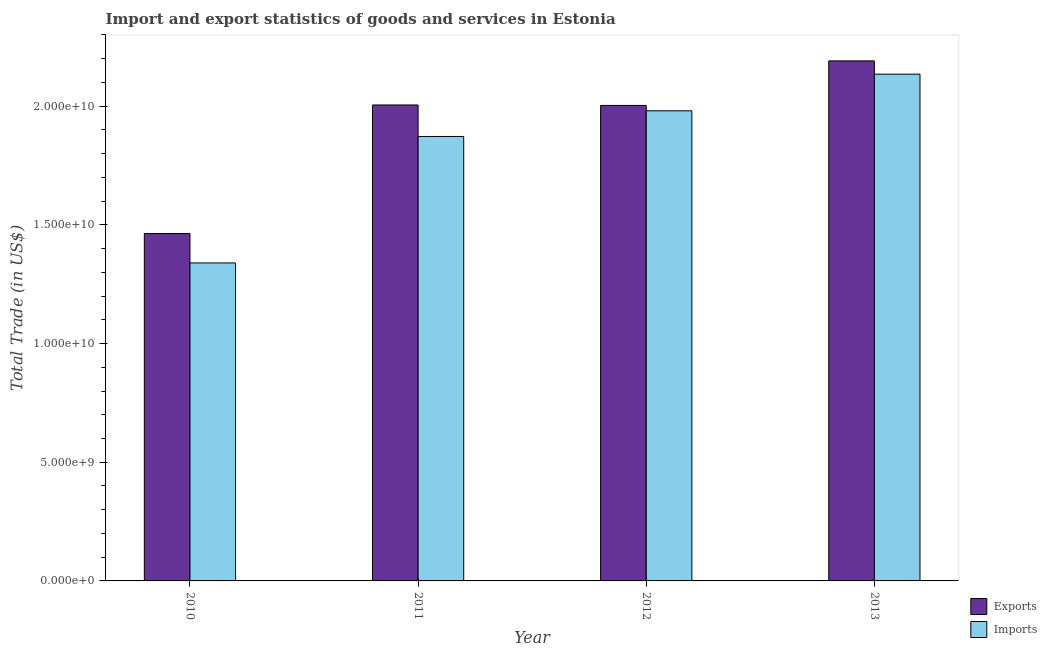Are the number of bars per tick equal to the number of legend labels?
Offer a terse response. Yes. How many bars are there on the 1st tick from the left?
Offer a very short reply. 2. How many bars are there on the 4th tick from the right?
Give a very brief answer. 2. What is the label of the 4th group of bars from the left?
Offer a very short reply. 2013. In how many cases, is the number of bars for a given year not equal to the number of legend labels?
Offer a very short reply. 0. What is the export of goods and services in 2012?
Offer a terse response. 2.00e+1. Across all years, what is the maximum imports of goods and services?
Give a very brief answer. 2.13e+1. Across all years, what is the minimum export of goods and services?
Your answer should be very brief. 1.46e+1. What is the total imports of goods and services in the graph?
Your response must be concise. 7.33e+1. What is the difference between the imports of goods and services in 2010 and that in 2012?
Keep it short and to the point. -6.41e+09. What is the difference between the export of goods and services in 2010 and the imports of goods and services in 2013?
Offer a terse response. -7.27e+09. What is the average export of goods and services per year?
Keep it short and to the point. 1.92e+1. What is the ratio of the imports of goods and services in 2011 to that in 2013?
Give a very brief answer. 0.88. Is the difference between the imports of goods and services in 2010 and 2012 greater than the difference between the export of goods and services in 2010 and 2012?
Ensure brevity in your answer.  No. What is the difference between the highest and the second highest export of goods and services?
Make the answer very short. 1.86e+09. What is the difference between the highest and the lowest export of goods and services?
Your answer should be compact. 7.27e+09. In how many years, is the export of goods and services greater than the average export of goods and services taken over all years?
Make the answer very short. 3. What does the 2nd bar from the left in 2010 represents?
Your answer should be very brief. Imports. What does the 2nd bar from the right in 2011 represents?
Provide a short and direct response. Exports. How many years are there in the graph?
Keep it short and to the point. 4. Where does the legend appear in the graph?
Make the answer very short. Bottom right. How many legend labels are there?
Offer a very short reply. 2. How are the legend labels stacked?
Provide a succinct answer. Vertical. What is the title of the graph?
Ensure brevity in your answer.  Import and export statistics of goods and services in Estonia. What is the label or title of the X-axis?
Provide a succinct answer. Year. What is the label or title of the Y-axis?
Ensure brevity in your answer.  Total Trade (in US$). What is the Total Trade (in US$) in Exports in 2010?
Make the answer very short. 1.46e+1. What is the Total Trade (in US$) in Imports in 2010?
Give a very brief answer. 1.34e+1. What is the Total Trade (in US$) of Exports in 2011?
Offer a terse response. 2.01e+1. What is the Total Trade (in US$) in Imports in 2011?
Ensure brevity in your answer.  1.87e+1. What is the Total Trade (in US$) of Exports in 2012?
Make the answer very short. 2.00e+1. What is the Total Trade (in US$) of Imports in 2012?
Offer a terse response. 1.98e+1. What is the Total Trade (in US$) of Exports in 2013?
Make the answer very short. 2.19e+1. What is the Total Trade (in US$) in Imports in 2013?
Ensure brevity in your answer.  2.13e+1. Across all years, what is the maximum Total Trade (in US$) of Exports?
Offer a very short reply. 2.19e+1. Across all years, what is the maximum Total Trade (in US$) in Imports?
Your answer should be compact. 2.13e+1. Across all years, what is the minimum Total Trade (in US$) of Exports?
Ensure brevity in your answer.  1.46e+1. Across all years, what is the minimum Total Trade (in US$) of Imports?
Ensure brevity in your answer.  1.34e+1. What is the total Total Trade (in US$) in Exports in the graph?
Provide a succinct answer. 7.66e+1. What is the total Total Trade (in US$) in Imports in the graph?
Ensure brevity in your answer.  7.33e+1. What is the difference between the Total Trade (in US$) of Exports in 2010 and that in 2011?
Provide a short and direct response. -5.42e+09. What is the difference between the Total Trade (in US$) in Imports in 2010 and that in 2011?
Make the answer very short. -5.33e+09. What is the difference between the Total Trade (in US$) of Exports in 2010 and that in 2012?
Your answer should be compact. -5.40e+09. What is the difference between the Total Trade (in US$) in Imports in 2010 and that in 2012?
Keep it short and to the point. -6.41e+09. What is the difference between the Total Trade (in US$) of Exports in 2010 and that in 2013?
Your response must be concise. -7.27e+09. What is the difference between the Total Trade (in US$) in Imports in 2010 and that in 2013?
Keep it short and to the point. -7.95e+09. What is the difference between the Total Trade (in US$) of Exports in 2011 and that in 2012?
Ensure brevity in your answer.  1.93e+07. What is the difference between the Total Trade (in US$) in Imports in 2011 and that in 2012?
Keep it short and to the point. -1.08e+09. What is the difference between the Total Trade (in US$) in Exports in 2011 and that in 2013?
Your response must be concise. -1.86e+09. What is the difference between the Total Trade (in US$) in Imports in 2011 and that in 2013?
Offer a very short reply. -2.63e+09. What is the difference between the Total Trade (in US$) in Exports in 2012 and that in 2013?
Your response must be concise. -1.88e+09. What is the difference between the Total Trade (in US$) of Imports in 2012 and that in 2013?
Ensure brevity in your answer.  -1.54e+09. What is the difference between the Total Trade (in US$) in Exports in 2010 and the Total Trade (in US$) in Imports in 2011?
Provide a short and direct response. -4.09e+09. What is the difference between the Total Trade (in US$) of Exports in 2010 and the Total Trade (in US$) of Imports in 2012?
Your response must be concise. -5.17e+09. What is the difference between the Total Trade (in US$) of Exports in 2010 and the Total Trade (in US$) of Imports in 2013?
Provide a succinct answer. -6.71e+09. What is the difference between the Total Trade (in US$) in Exports in 2011 and the Total Trade (in US$) in Imports in 2012?
Give a very brief answer. 2.46e+08. What is the difference between the Total Trade (in US$) in Exports in 2011 and the Total Trade (in US$) in Imports in 2013?
Make the answer very short. -1.30e+09. What is the difference between the Total Trade (in US$) of Exports in 2012 and the Total Trade (in US$) of Imports in 2013?
Keep it short and to the point. -1.32e+09. What is the average Total Trade (in US$) of Exports per year?
Ensure brevity in your answer.  1.92e+1. What is the average Total Trade (in US$) of Imports per year?
Provide a short and direct response. 1.83e+1. In the year 2010, what is the difference between the Total Trade (in US$) of Exports and Total Trade (in US$) of Imports?
Your response must be concise. 1.24e+09. In the year 2011, what is the difference between the Total Trade (in US$) in Exports and Total Trade (in US$) in Imports?
Make the answer very short. 1.33e+09. In the year 2012, what is the difference between the Total Trade (in US$) in Exports and Total Trade (in US$) in Imports?
Provide a succinct answer. 2.26e+08. In the year 2013, what is the difference between the Total Trade (in US$) in Exports and Total Trade (in US$) in Imports?
Ensure brevity in your answer.  5.60e+08. What is the ratio of the Total Trade (in US$) in Exports in 2010 to that in 2011?
Make the answer very short. 0.73. What is the ratio of the Total Trade (in US$) of Imports in 2010 to that in 2011?
Your answer should be very brief. 0.72. What is the ratio of the Total Trade (in US$) in Exports in 2010 to that in 2012?
Your answer should be compact. 0.73. What is the ratio of the Total Trade (in US$) of Imports in 2010 to that in 2012?
Provide a succinct answer. 0.68. What is the ratio of the Total Trade (in US$) in Exports in 2010 to that in 2013?
Keep it short and to the point. 0.67. What is the ratio of the Total Trade (in US$) of Imports in 2010 to that in 2013?
Your answer should be compact. 0.63. What is the ratio of the Total Trade (in US$) of Imports in 2011 to that in 2012?
Keep it short and to the point. 0.95. What is the ratio of the Total Trade (in US$) in Exports in 2011 to that in 2013?
Provide a succinct answer. 0.92. What is the ratio of the Total Trade (in US$) in Imports in 2011 to that in 2013?
Offer a terse response. 0.88. What is the ratio of the Total Trade (in US$) of Exports in 2012 to that in 2013?
Offer a very short reply. 0.91. What is the ratio of the Total Trade (in US$) of Imports in 2012 to that in 2013?
Keep it short and to the point. 0.93. What is the difference between the highest and the second highest Total Trade (in US$) in Exports?
Keep it short and to the point. 1.86e+09. What is the difference between the highest and the second highest Total Trade (in US$) in Imports?
Make the answer very short. 1.54e+09. What is the difference between the highest and the lowest Total Trade (in US$) in Exports?
Provide a short and direct response. 7.27e+09. What is the difference between the highest and the lowest Total Trade (in US$) in Imports?
Provide a short and direct response. 7.95e+09. 